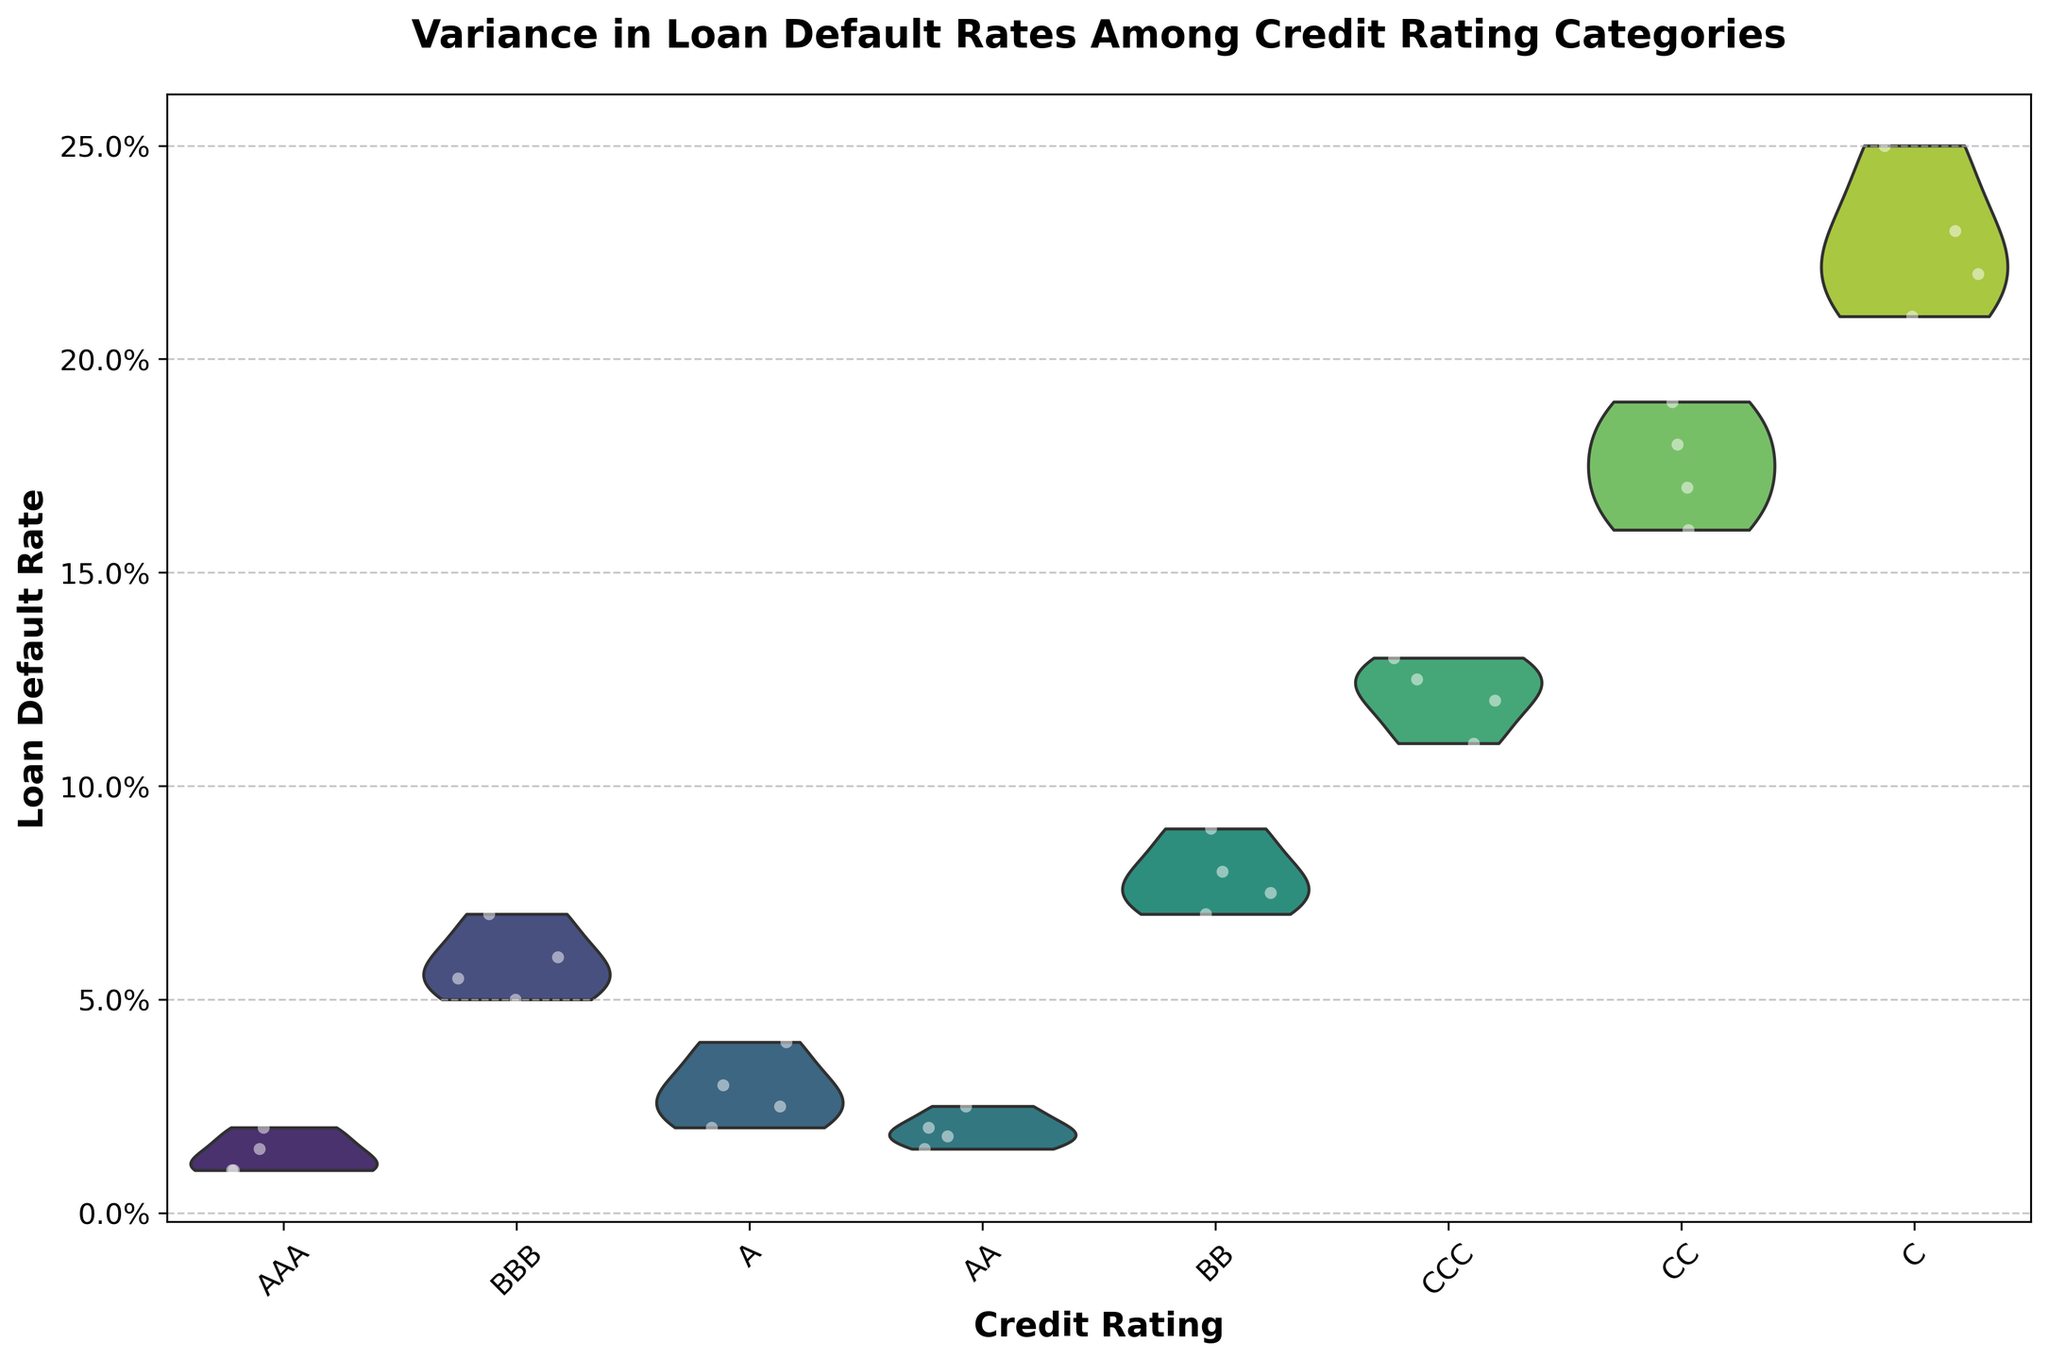What is the title of the chart? The title is typically displayed at the top of the chart in a bold and larger font size compared to other text elements. In this case, the title is "Variance in Loan Default Rates Among Credit Rating Categories".
Answer: Variance in Loan Default Rates Among Credit Rating Categories Which credit rating category has the highest median loan default rate? In a violin plot, the width of the violin at different y-values indicates the density of data points. The white line in the middle of each violin represents the median value. For the category with the highest median line, look at all the violins and compare their middle points.
Answer: C How do the average default rates compare between AAA and CCC ratings? The average is visually estimated by the density and central tendency of the data points around the middle of the violin. By looking at the violins for AAA and CCC, we can see that CCC has a higher central tendency (middle part of the violin is positioned higher on the y-axis) than AAA.
Answer: CCC > AAA Which category has the most widely spread loan default rates? The spread can be assessed by looking at the height of the violin along the y-axis. The category with the tallest overall violin represents the widest spread.
Answer: C What is the approximate range of default rates for the BBB rating? The range is the difference between the highest and lowest y-values within the violin for BBB. The BBB violin stretches approximately from 0.05 to 0.07.
Answer: 0.05 to 0.07 Compare the default rates of BB and CC ratings; which has a larger spread? The spread (or variance) is visually detected by comparing the height of the violins. BB and CC both have large spreads, but CC spreads from 0.16 to 0.19 while BB spreads from 0.07 to 0.09.
Answer: CC How does the y-axis represent the loan default rate in the chart? The y-axis measures the loan default rates, often expressed as a percentage. The format of the scale goes from 0.00 to 0.25, indicating the default rates. The grid lines and labels help to read specific values.
Answer: As a percentage scale What is the default rate range for AA rating, and how does it compare with A rating? To find the range, observe the extent of the violin on the y-axis. The AA category spans from approximately 0.015 to 0.025. For the A rating, it spans from around 0.02 to 0.04. Comparing both ranges, the A rating has a wider range.
Answer: AA: 0.015 to 0.025, A: 0.02 to 0.04 Which credit rating categories have data points with less variance? Categories with shorter violins relative to their y-axis represent less variance. In this chart, AA and AAA have the shortest violins, indicating a more concentrated set of data points.
Answer: AA and AAA 